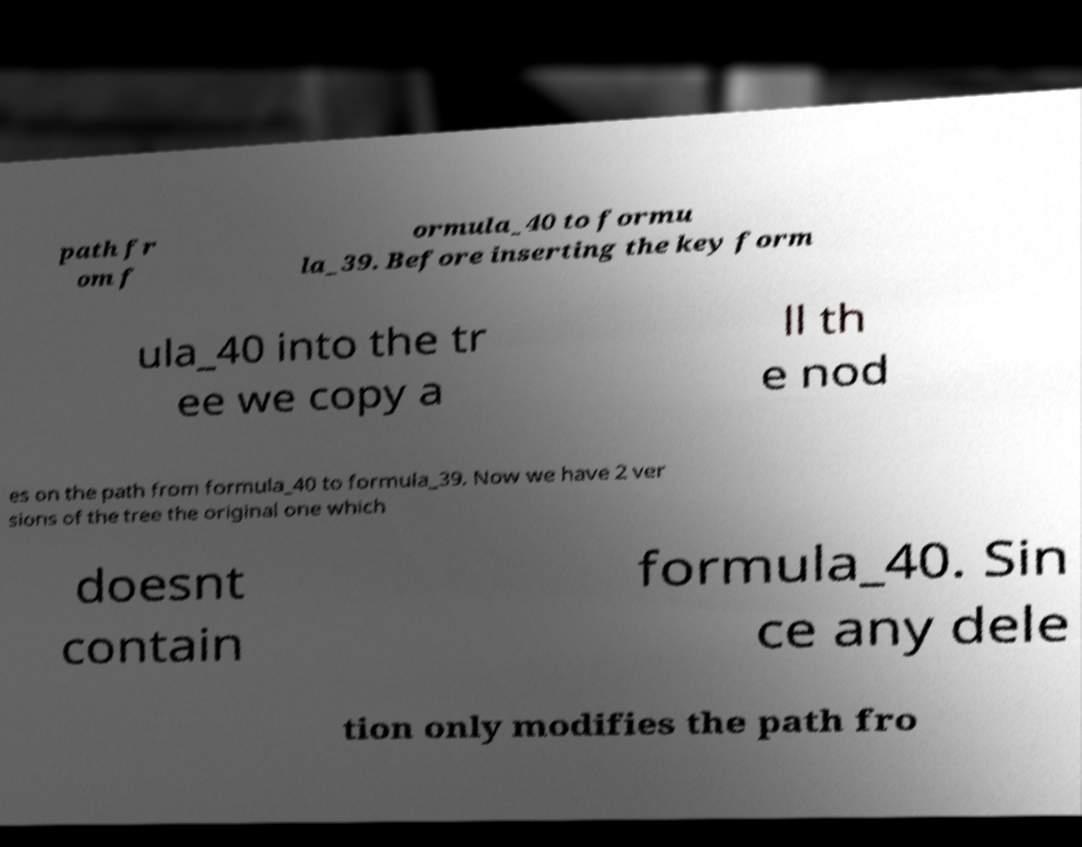Could you assist in decoding the text presented in this image and type it out clearly? path fr om f ormula_40 to formu la_39. Before inserting the key form ula_40 into the tr ee we copy a ll th e nod es on the path from formula_40 to formula_39. Now we have 2 ver sions of the tree the original one which doesnt contain formula_40. Sin ce any dele tion only modifies the path fro 